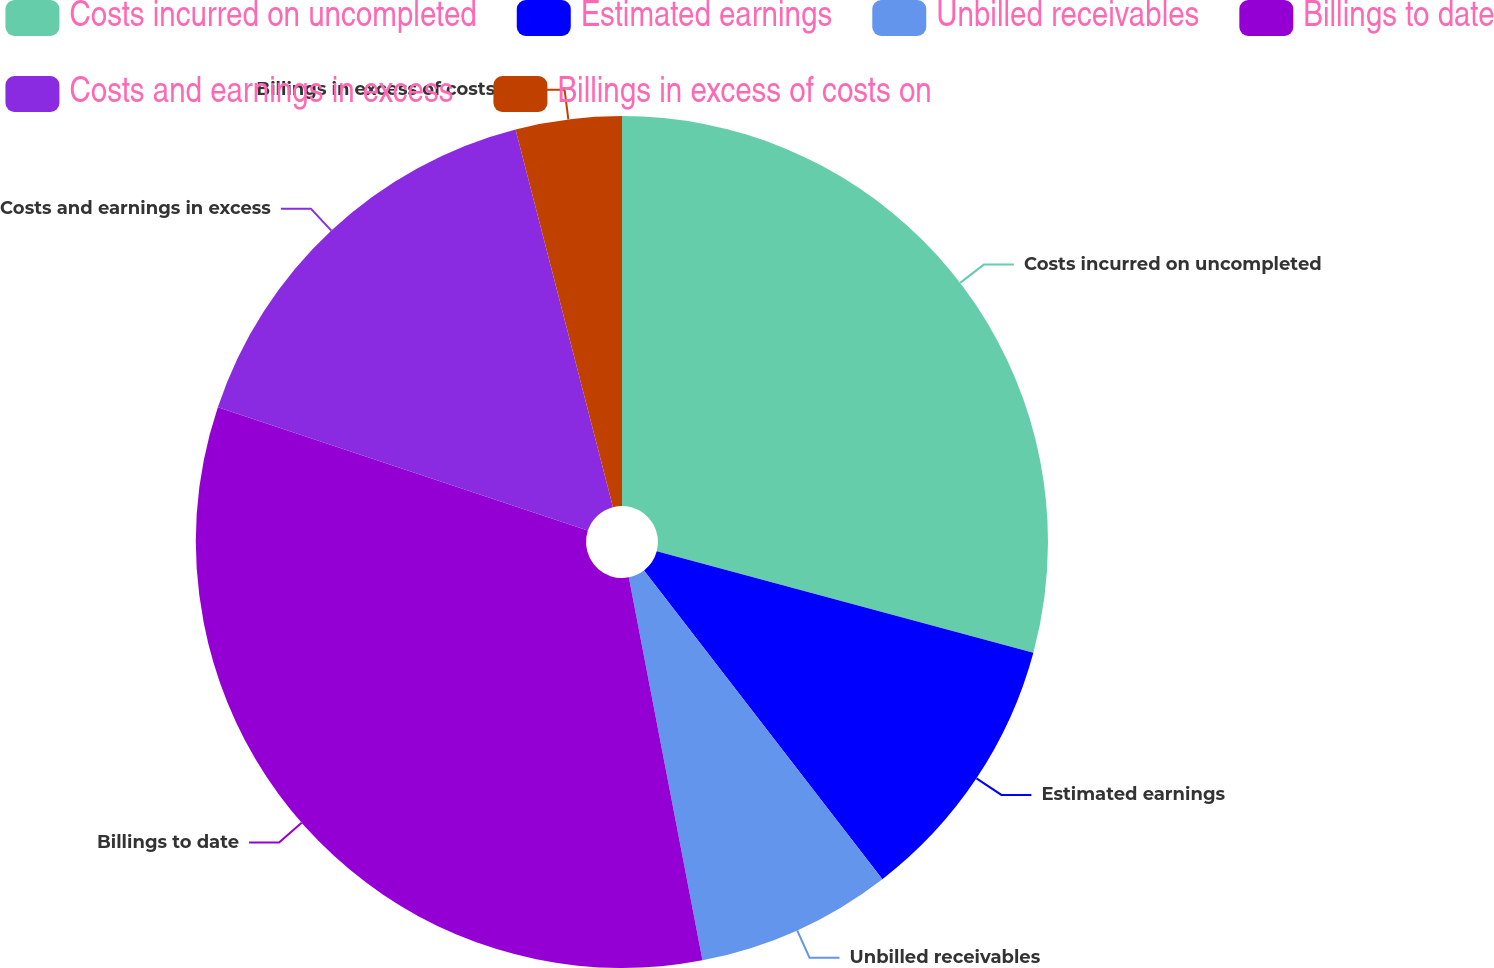Convert chart to OTSL. <chart><loc_0><loc_0><loc_500><loc_500><pie_chart><fcel>Costs incurred on uncompleted<fcel>Estimated earnings<fcel>Unbilled receivables<fcel>Billings to date<fcel>Costs and earnings in excess<fcel>Billings in excess of costs on<nl><fcel>29.18%<fcel>10.35%<fcel>7.44%<fcel>33.14%<fcel>15.86%<fcel>4.02%<nl></chart> 